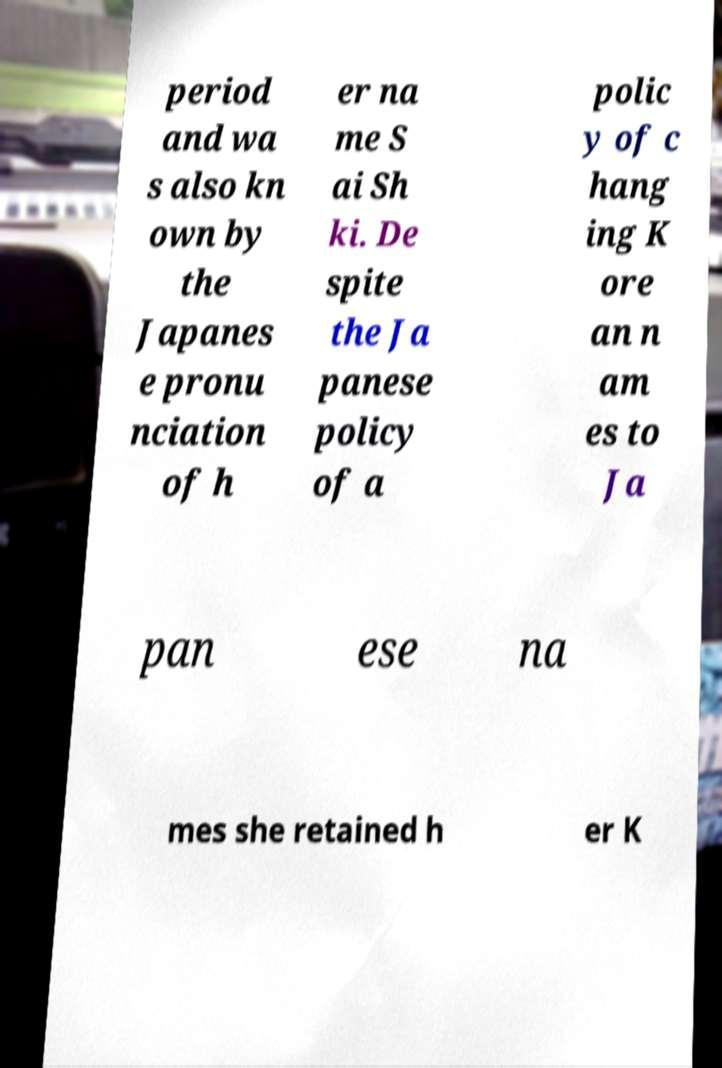Could you extract and type out the text from this image? period and wa s also kn own by the Japanes e pronu nciation of h er na me S ai Sh ki. De spite the Ja panese policy of a polic y of c hang ing K ore an n am es to Ja pan ese na mes she retained h er K 